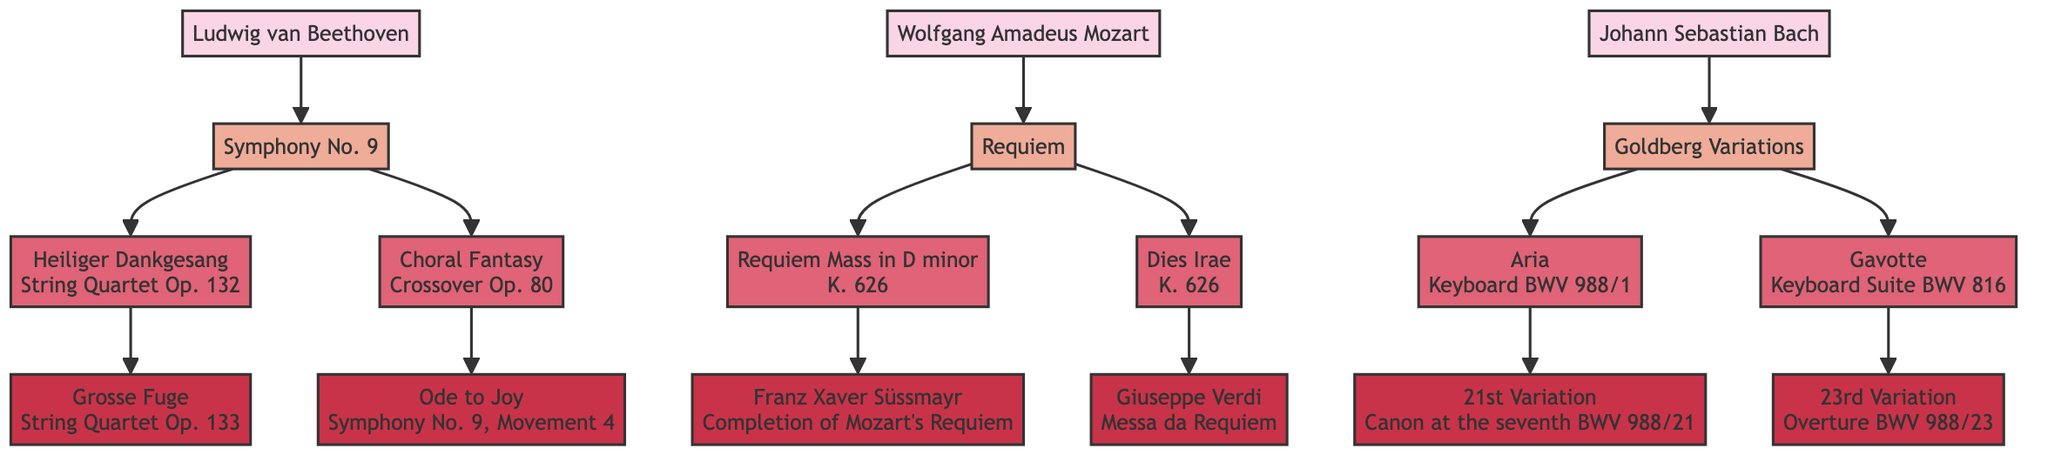What is the main composition of Ludwig van Beethoven? The diagram shows Ludwig van Beethoven as the composer connected to the composition "Symphony No. 9."
Answer: Symphony No. 9 How many variants does Mozart's Requiem have? The diagram indicates that Mozart's Requiem has two variants: "Requiem Mass in D minor" and "Dies Irae."
Answer: 2 Who completed Mozart's Requiem? The diagram connects Franz Xaver Süssmayr to the variant "Requiem Mass in D minor," indicating he completed it.
Answer: Franz Xaver Süssmayr Which composition did the "21st Variation" influence? The "21st Variation" is shown as influencing the "Aria" variant from the "Goldberg Variations" composed by Johann Sebastian Bach.
Answer: Aria What type of work is the "Choral Fantasy"? The diagram clearly categorizes "Choral Fantasy" as a "Crossover" type of work under Beethoven's variants of "Symphony No. 9."
Answer: Crossover What is the relationship between "Dies Irae" and "Messa da Requiem"? The diagram shows that "Dies Irae" inspired Giuseppe Verdi's work "Messa da Requiem," indicating a derivative relationship.
Answer: Derivative How many composers are represented in the diagram? The diagram displays three composers: Ludwig van Beethoven, Wolfgang Amadeus Mozart, and Johann Sebastian Bach.
Answer: 3 What instrument type is the "Aria" variant categorized as? The diagram specifies that "Aria" is a "Keyboard" variant within Bach's "Goldberg Variations."
Answer: Keyboard Which Brandenburg Concerto variant influences the "23rd Variation"? The "23rd Variation" is influenced by the "Gavotte" variant shown in the diagram, which is categorized as a "Keyboard Suite."
Answer: Gavotte 